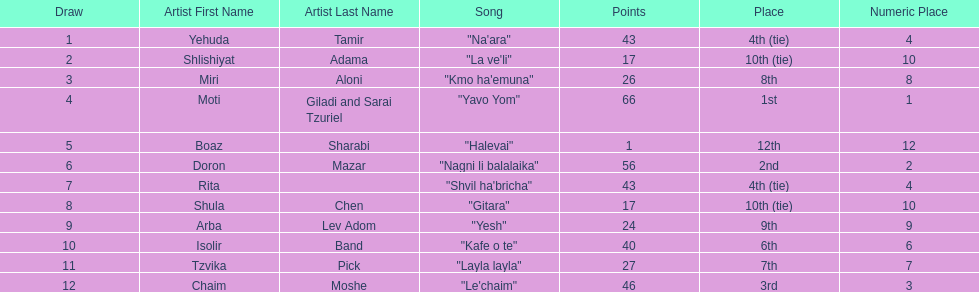What is the name of the first song listed on this chart? "Na'ara". 